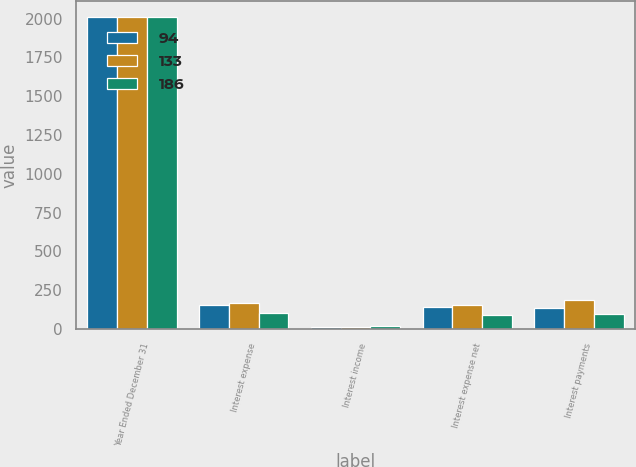Convert chart to OTSL. <chart><loc_0><loc_0><loc_500><loc_500><stacked_bar_chart><ecel><fcel>Year Ended December 31<fcel>Interest expense<fcel>Interest income<fcel>Interest expense net<fcel>Interest payments<nl><fcel>94<fcel>2011<fcel>155<fcel>14<fcel>141<fcel>133<nl><fcel>133<fcel>2012<fcel>168<fcel>12<fcel>156<fcel>186<nl><fcel>186<fcel>2013<fcel>103<fcel>17<fcel>86<fcel>94<nl></chart> 